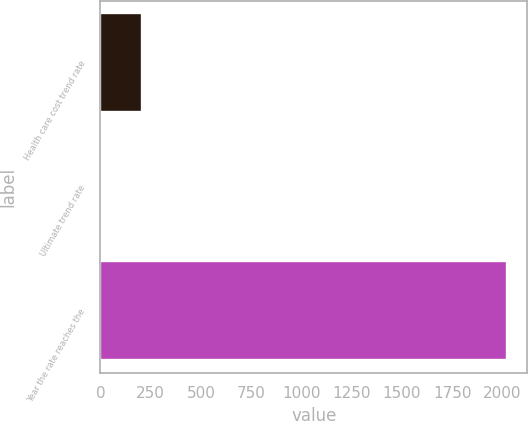Convert chart to OTSL. <chart><loc_0><loc_0><loc_500><loc_500><bar_chart><fcel>Health care cost trend rate<fcel>Ultimate trend rate<fcel>Year the rate reaches the<nl><fcel>206.25<fcel>4.5<fcel>2022<nl></chart> 